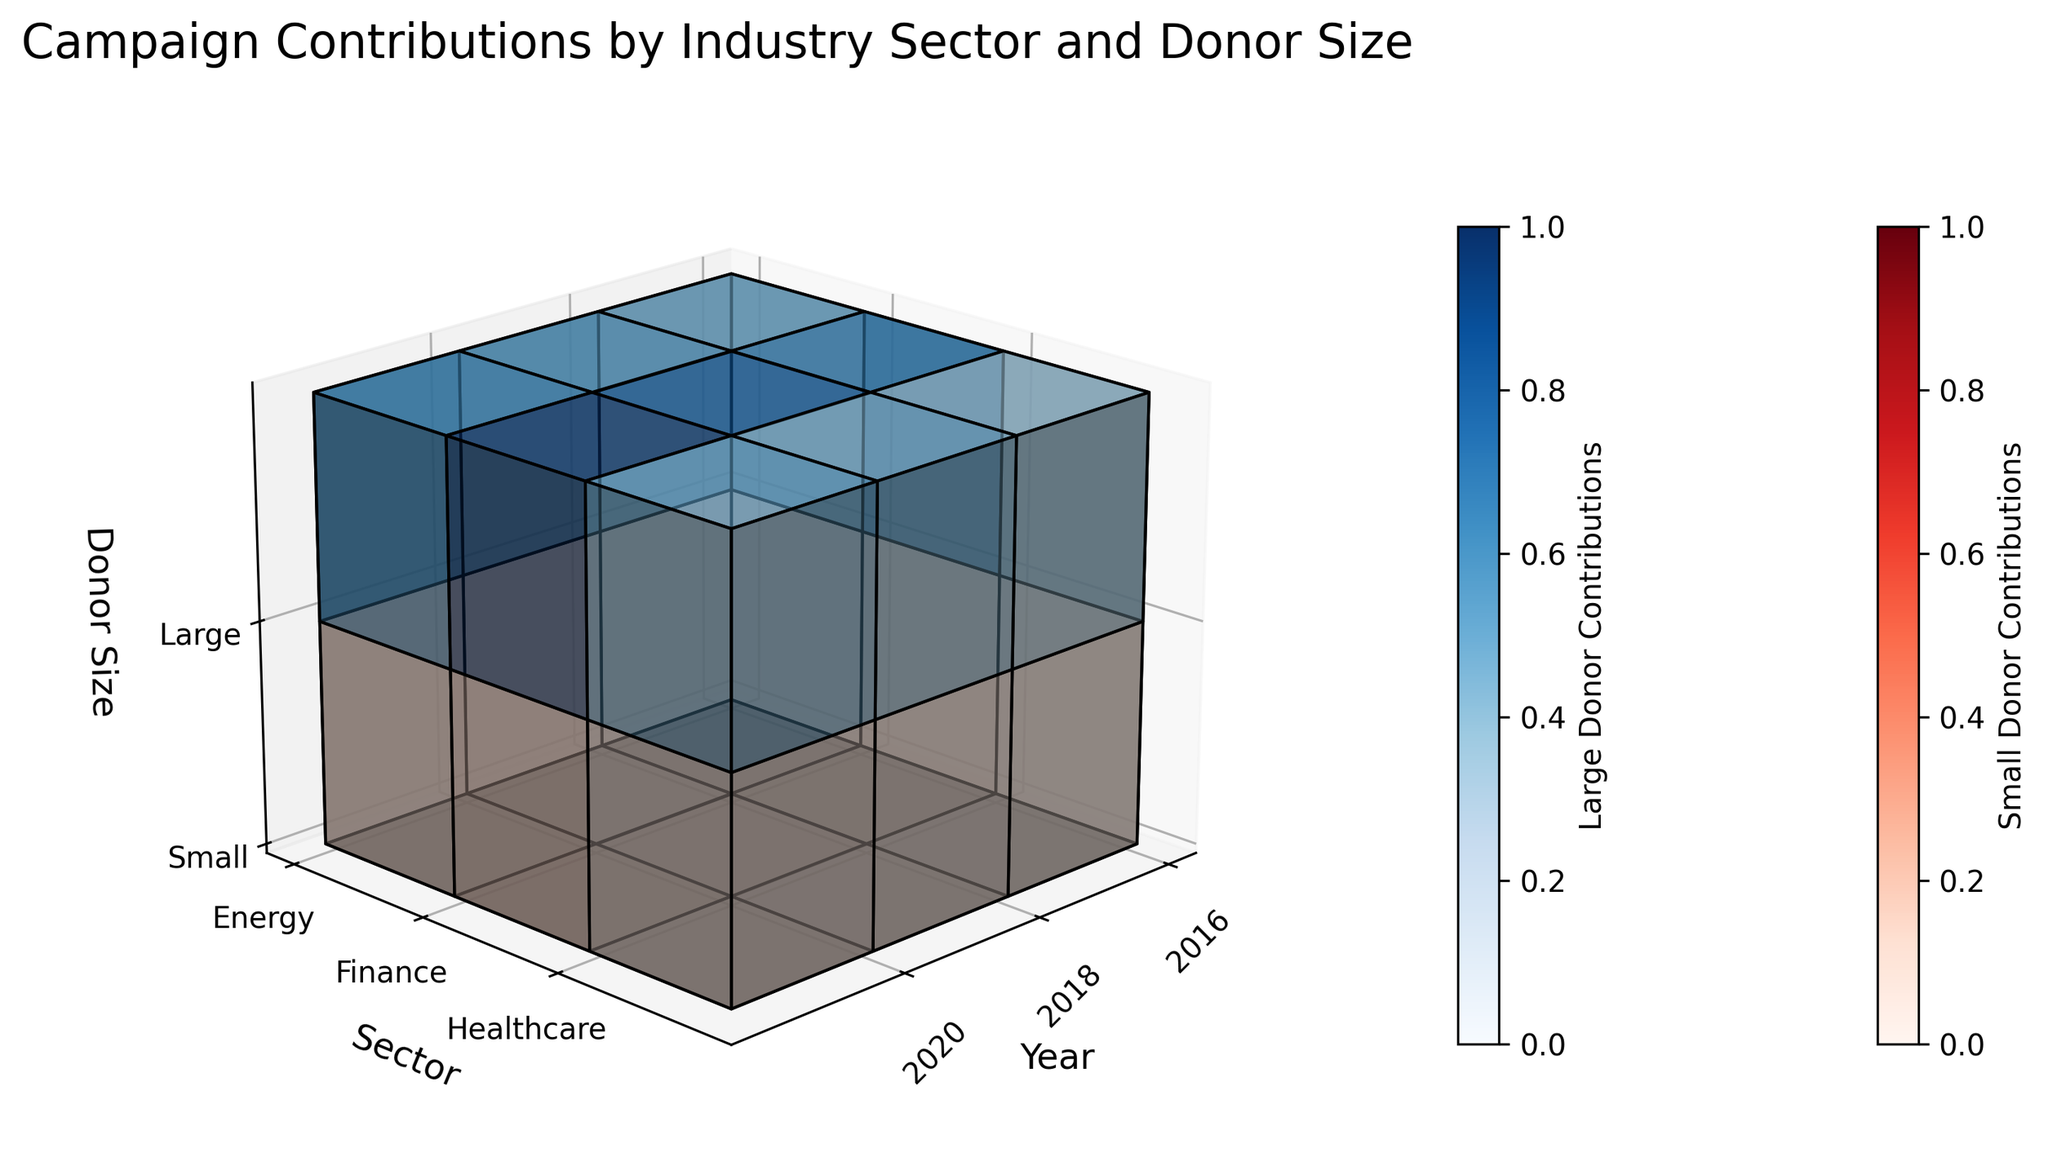What is the range of years shown in the plot? The x-axis represents the years, and based on the figure, the years range from 2016 to 2020.
Answer: 2016 to 2020 How are the sectors differentiated in the plot? The y-axis labels represent different sectors, which include Energy, Finance, and Healthcare.
Answer: Energy, Finance, and Healthcare Which donor size has the highest campaign contribution in 2020 for the Finance sector? For the year 2020 and the Finance sector, the large donors have the highest contribution, as indicated by the color shading (darker blue) and voxel size.
Answer: Large What trend can be observed in the contributions from small donors in the Healthcare sector over the years? Observing the color intensity and size of the voxels on the z-axis for small donors in the Healthcare sector from 2016 to 2020, the contributions have increased, reflecting a steady growth (shaded from lighter to darker red).
Answer: Increased How do contributions from large donors in the Energy sector compare between 2016 and 2018? Comparing the color intensity and size of the voxels for large donors in the Energy sector between 2016 and 2018, contributions rose from about 8.5 million to 10 million, indicating an increase.
Answer: Increased Are there any sectors where contributions from large donors decreased from 2016 to 2020? By examining the voxels’ colors and sizes for large donors across the sectors from 2016 to 2020, there isn’t a decrease in any sector; either contributions increased or remained the same.
Answer: No Which donor size in the Finance sector shows the most significant increase in contributions from 2016 to 2020? In the Finance sector, observing the change in voxel size and color for both donor sizes from 2016 to 2020, large donors show the most significant increase, as contributions rose notably from 12 million to 18 million.
Answer: Large What is the main title of the plot? The main title is displayed at the top of the plot and reads "Campaign Contributions by Industry Sector and Donor Size."
Answer: Campaign Contributions by Industry Sector and Donor Size In which year did small donors in the Finance sector contribute the least? When examining the color intensity and size of the voxels for small donors in the Finance sector across different years, the lowest contribution was made in 2016.
Answer: 2016 How does the contribution from large donors in the Healthcare sector in 2018 compare to contributions from small donors in the same sector and year? By comparing the voxel sizes and colors for large and small donors in the Healthcare sector in 2018, large donors contributed significantly more, reflected by a much larger voxel shaded in dark blue.
Answer: Significantly more 